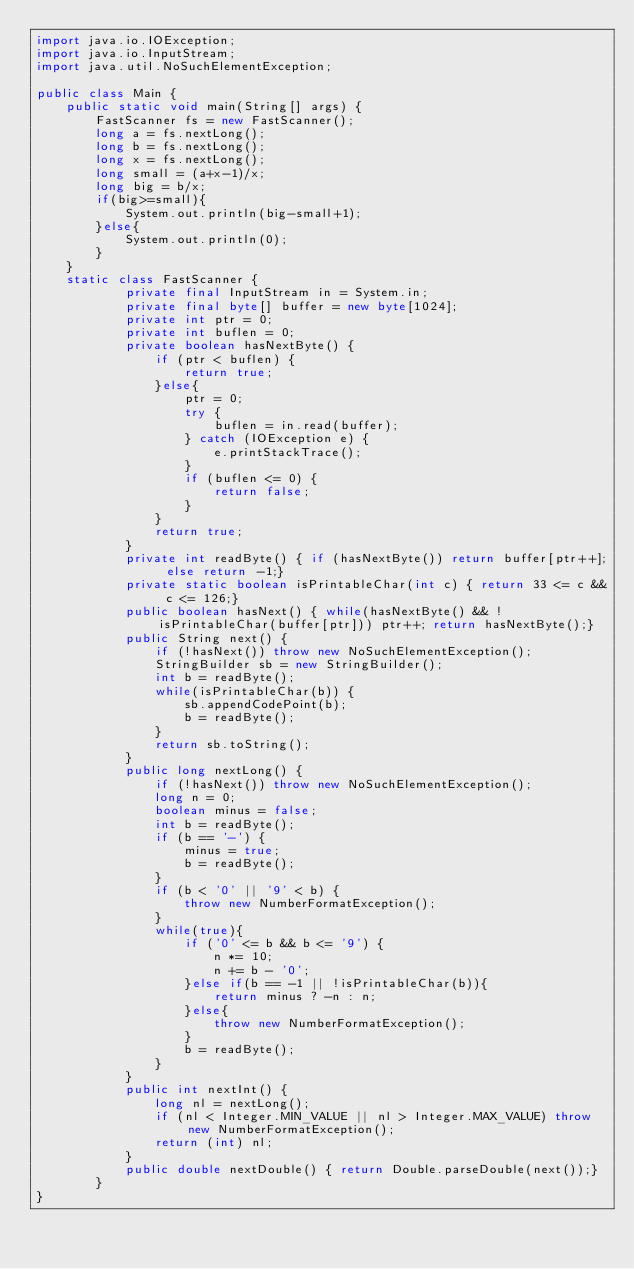<code> <loc_0><loc_0><loc_500><loc_500><_Java_>import java.io.IOException;
import java.io.InputStream;
import java.util.NoSuchElementException;

public class Main {
    public static void main(String[] args) {
        FastScanner fs = new FastScanner();
        long a = fs.nextLong();
        long b = fs.nextLong();
        long x = fs.nextLong();
        long small = (a+x-1)/x;
        long big = b/x;
        if(big>=small){
            System.out.println(big-small+1);
        }else{
            System.out.println(0);
        }
    }
    static class FastScanner {
            private final InputStream in = System.in;
            private final byte[] buffer = new byte[1024];
            private int ptr = 0;
            private int buflen = 0;
            private boolean hasNextByte() {
                if (ptr < buflen) {
                    return true;
                }else{
                    ptr = 0;
                    try {
                        buflen = in.read(buffer);
                    } catch (IOException e) {
                        e.printStackTrace();
                    }
                    if (buflen <= 0) {
                        return false;
                    }
                }
                return true;
            }
            private int readByte() { if (hasNextByte()) return buffer[ptr++]; else return -1;}
            private static boolean isPrintableChar(int c) { return 33 <= c && c <= 126;}
            public boolean hasNext() { while(hasNextByte() && !isPrintableChar(buffer[ptr])) ptr++; return hasNextByte();}
            public String next() {
                if (!hasNext()) throw new NoSuchElementException();
                StringBuilder sb = new StringBuilder();
                int b = readByte();
                while(isPrintableChar(b)) {
                    sb.appendCodePoint(b);
                    b = readByte();
                }
                return sb.toString();
            }
            public long nextLong() {
                if (!hasNext()) throw new NoSuchElementException();
                long n = 0;
                boolean minus = false;
                int b = readByte();
                if (b == '-') {
                    minus = true;
                    b = readByte();
                }
                if (b < '0' || '9' < b) {
                    throw new NumberFormatException();
                }
                while(true){
                    if ('0' <= b && b <= '9') {
                        n *= 10;
                        n += b - '0';
                    }else if(b == -1 || !isPrintableChar(b)){
                        return minus ? -n : n;
                    }else{
                        throw new NumberFormatException();
                    }
                    b = readByte();
                }
            }
            public int nextInt() {
                long nl = nextLong();
                if (nl < Integer.MIN_VALUE || nl > Integer.MAX_VALUE) throw new NumberFormatException();
                return (int) nl;
            }
            public double nextDouble() { return Double.parseDouble(next());}
        }
}
</code> 